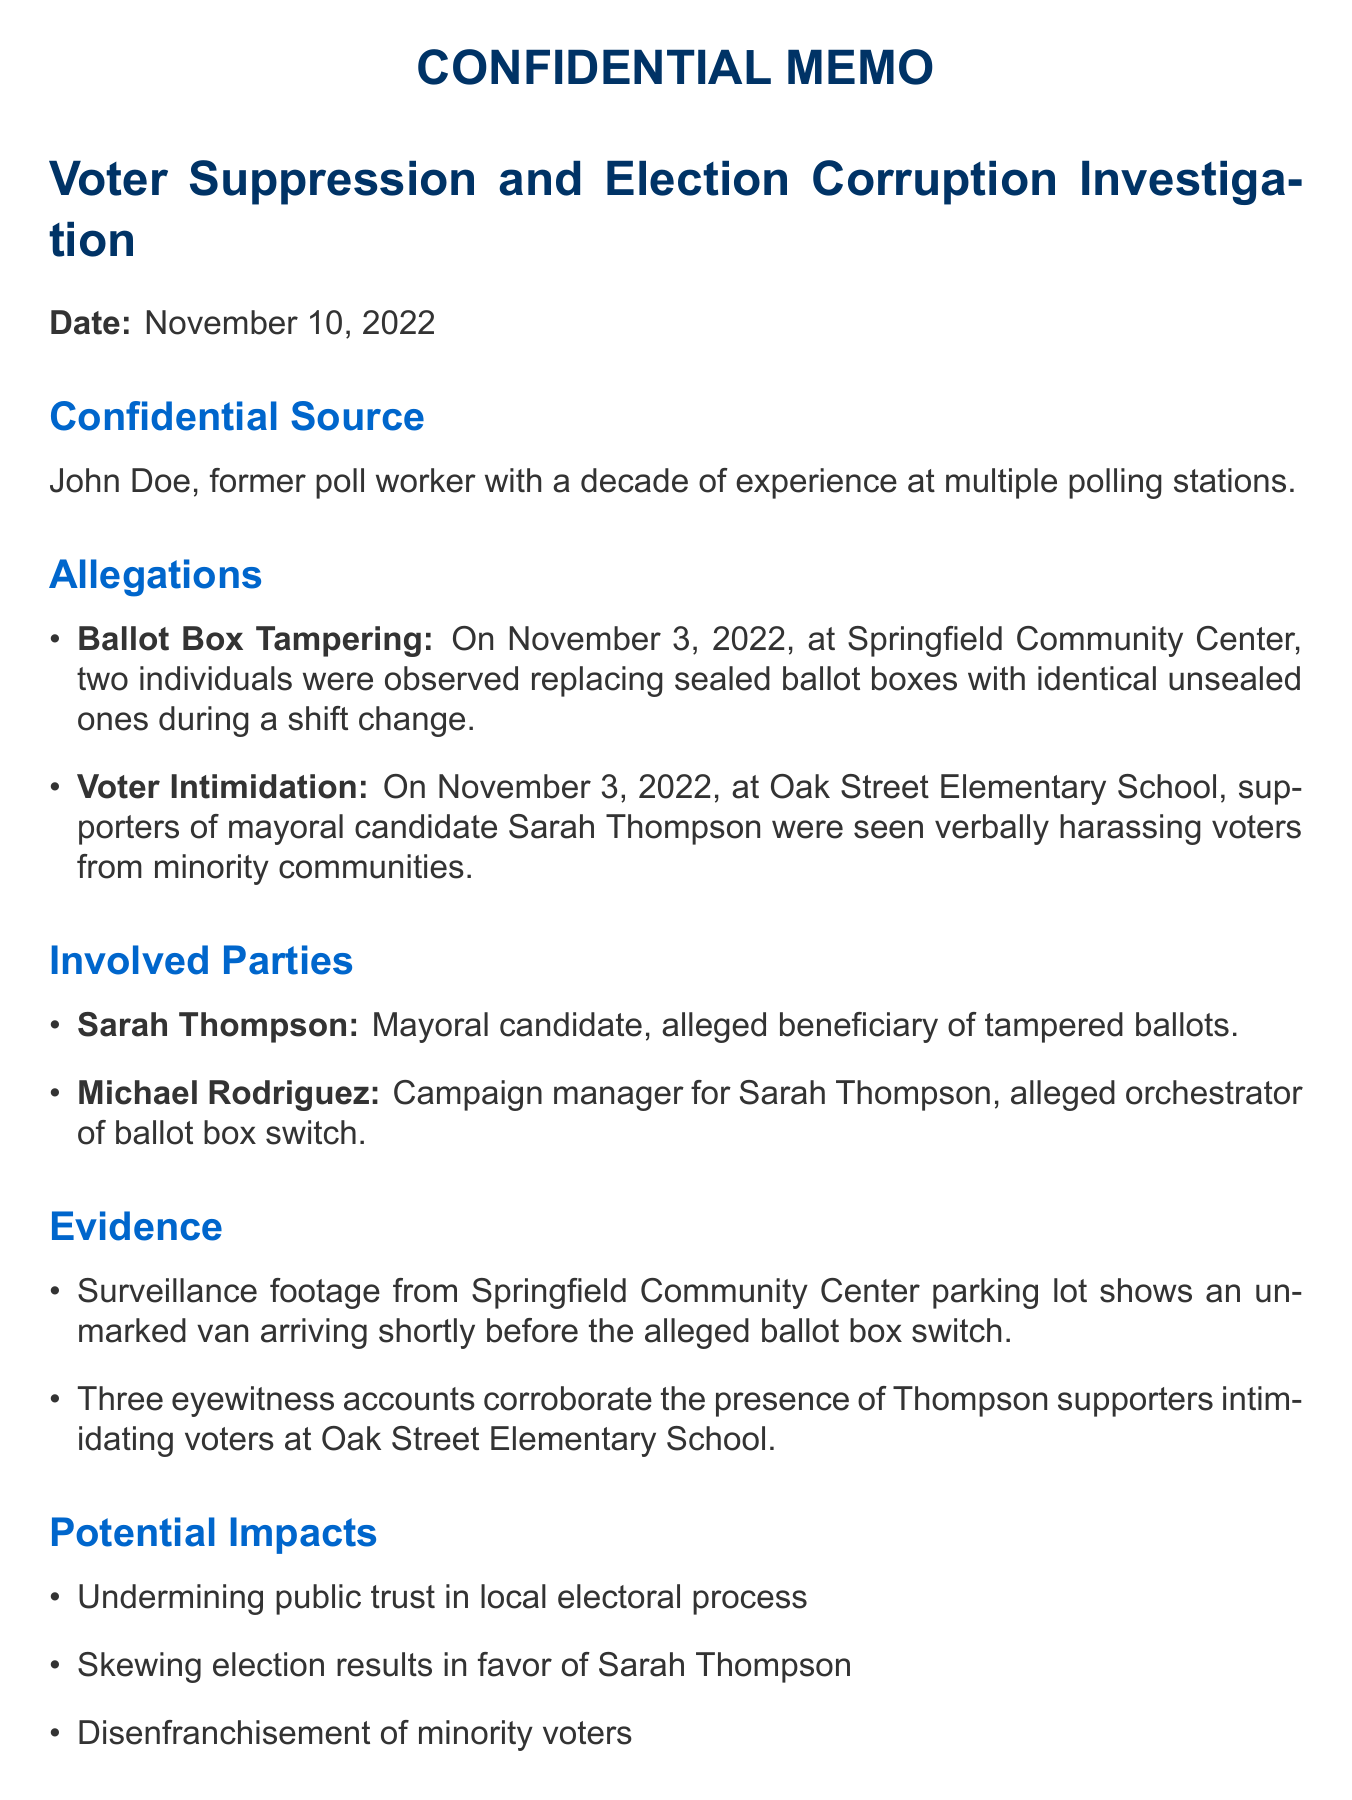What is the name of the confidential source? The name of the confidential source is provided in the document and is "John Doe."
Answer: John Doe What allegations were made at Springfield Community Center? The allegations made relate to ballot box tampering observed during a shift change.
Answer: Ballot box tampering What date did the incidents occur? The memo specifies that the incidents occurred on November 3, 2022.
Answer: November 3, 2022 Who is the campaign manager mentioned in connection with Sarah Thompson? The document identifies Michael Rodriguez as the campaign manager for Sarah Thompson.
Answer: Michael Rodriguez How many eyewitness accounts support the allegations of voter intimidation? The document states that there are three eyewitness accounts that support the allegations.
Answer: 3 What is a potential impact of the alleged tampering? The document lists several potential impacts, including undermining public trust in local electoral process.
Answer: Undermining public trust in local electoral process What steps are proposed for the next actions? The memo outlines specific next steps, including interviewing additional poll workers.
Answer: Interview additional poll workers from affected locations What kind of footage is mentioned as evidence? The memo refers to surveillance footage from the parking lot of Springfield Community Center as evidence.
Answer: Surveillance footage Who are the candidates mentioned in the election details? The candidates listed in the election details are Sarah Thompson, David Chen, and Lisa Gonzalez.
Answer: Sarah Thompson, David Chen, Lisa Gonzalez 